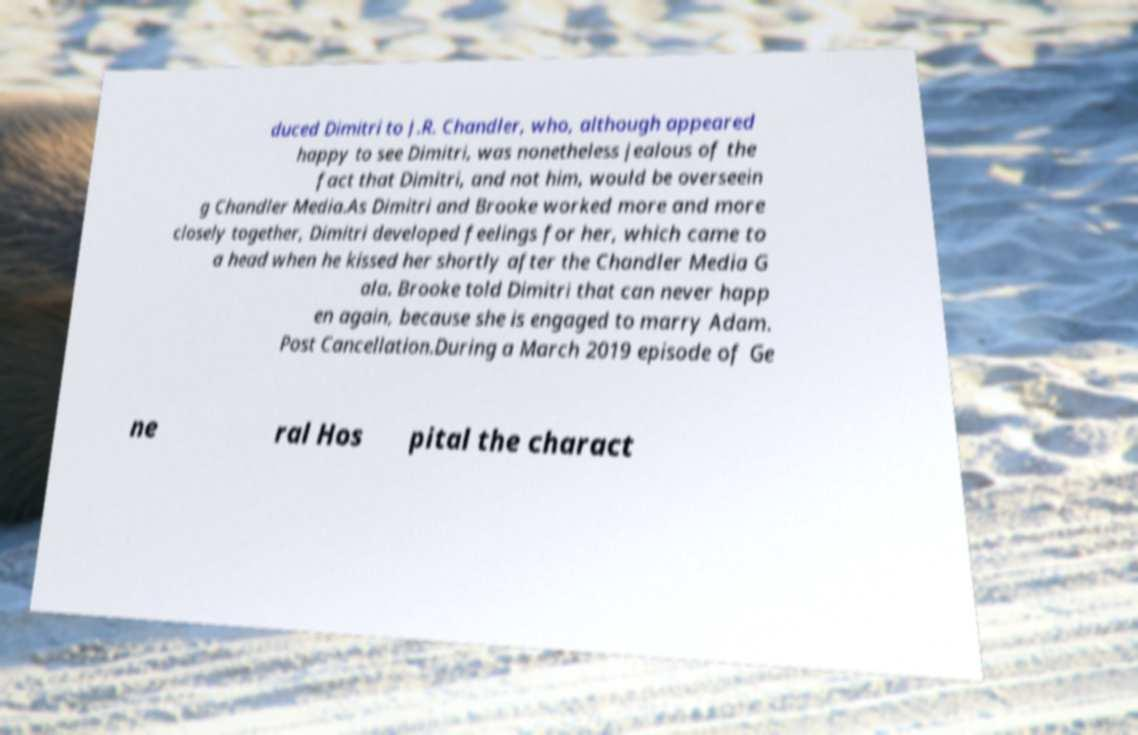Please read and relay the text visible in this image. What does it say? duced Dimitri to J.R. Chandler, who, although appeared happy to see Dimitri, was nonetheless jealous of the fact that Dimitri, and not him, would be overseein g Chandler Media.As Dimitri and Brooke worked more and more closely together, Dimitri developed feelings for her, which came to a head when he kissed her shortly after the Chandler Media G ala. Brooke told Dimitri that can never happ en again, because she is engaged to marry Adam. Post Cancellation.During a March 2019 episode of Ge ne ral Hos pital the charact 